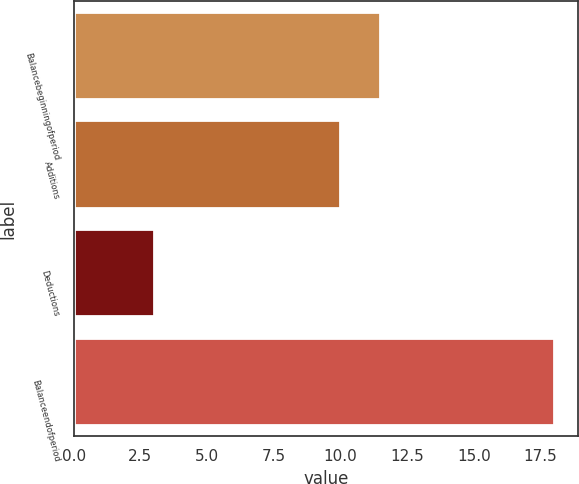Convert chart. <chart><loc_0><loc_0><loc_500><loc_500><bar_chart><fcel>Balancebeginningofperiod<fcel>Additions<fcel>Deductions<fcel>Balanceendofperiod<nl><fcel>11.5<fcel>10<fcel>3<fcel>18<nl></chart> 